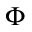Convert formula to latex. <formula><loc_0><loc_0><loc_500><loc_500>\Phi</formula> 